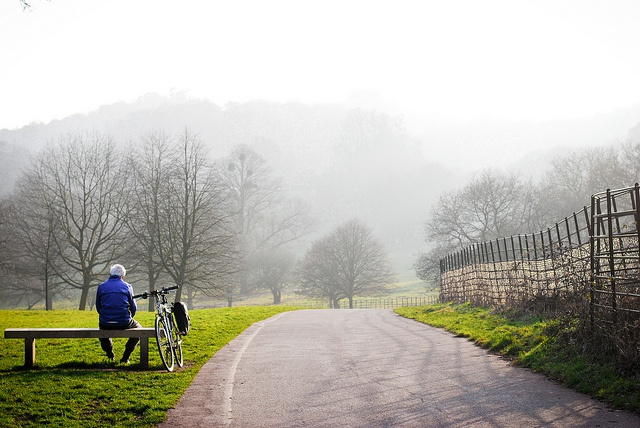Describe the objects in this image and their specific colors. I can see people in white, black, navy, darkblue, and darkgray tones, bench in white, black, lightgray, and darkgreen tones, bicycle in white, black, gray, darkgray, and lightgray tones, and backpack in white, black, gray, and tan tones in this image. 